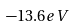Convert formula to latex. <formula><loc_0><loc_0><loc_500><loc_500>- 1 3 . 6 e V</formula> 